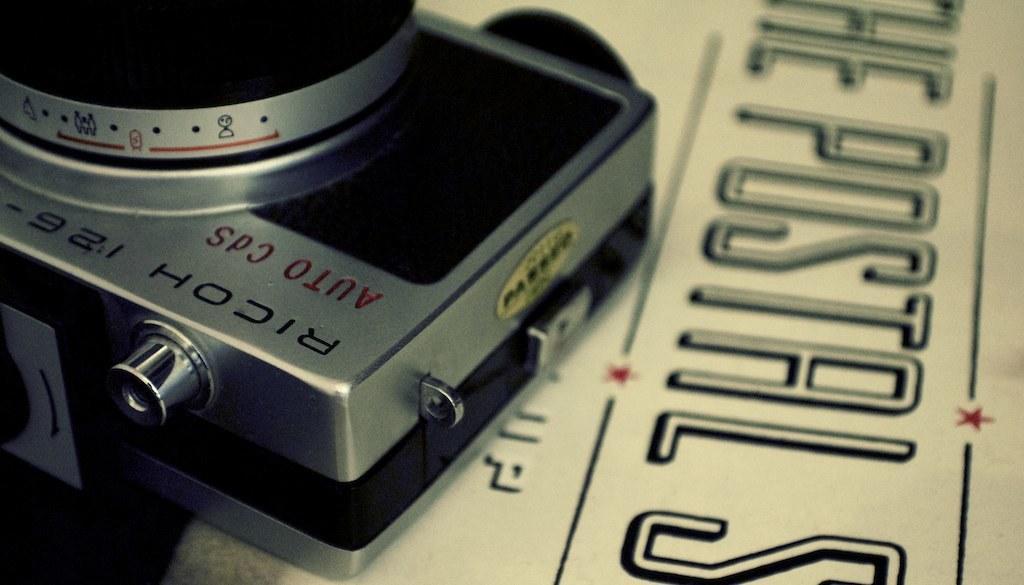Please provide a concise description of this image. On the left side of this image I can see a camera which is placed on a newspaper. On this paper I can see some text in black color. 